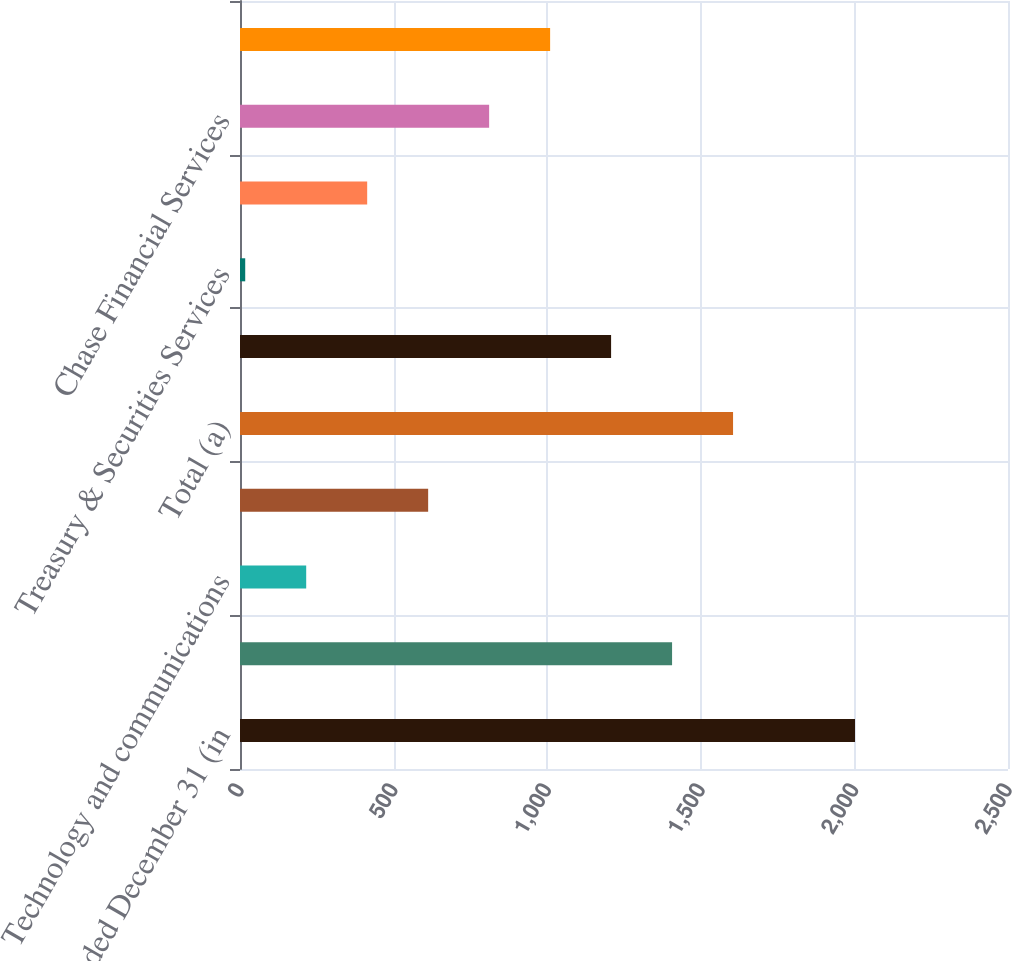Convert chart. <chart><loc_0><loc_0><loc_500><loc_500><bar_chart><fcel>Year ended December 31 (in<fcel>Compensation<fcel>Technology and communications<fcel>Other<fcel>Total (a)<fcel>Investment Bank<fcel>Treasury & Securities Services<fcel>Investment Management &<fcel>Chase Financial Services<fcel>Support Units and Corporate<nl><fcel>2002<fcel>1406.5<fcel>215.5<fcel>612.5<fcel>1605<fcel>1208<fcel>17<fcel>414<fcel>811<fcel>1009.5<nl></chart> 